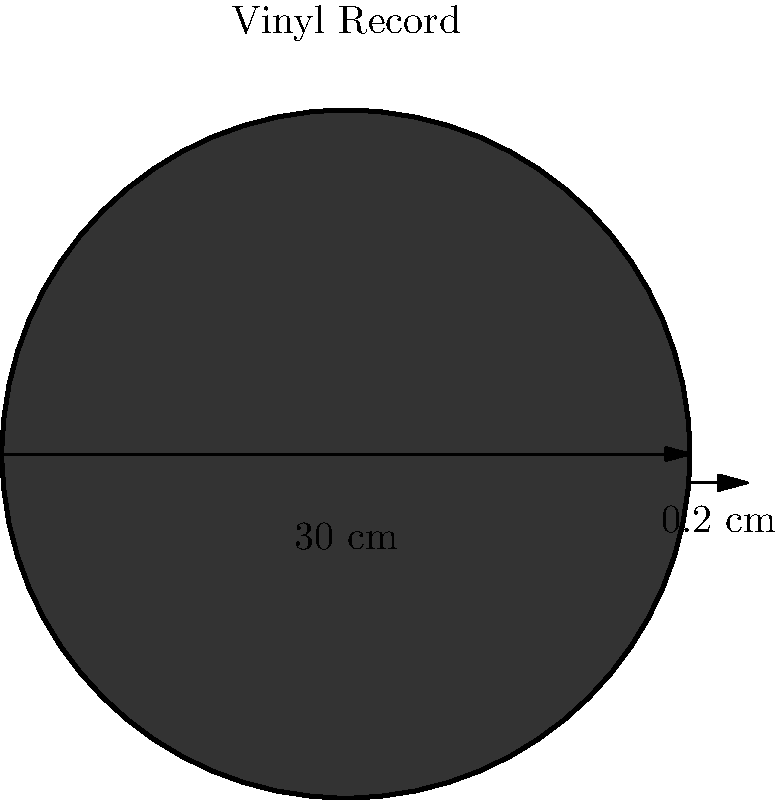As a vinyl record collector, you're curious about the volume of your favorite records. Given a standard 12-inch vinyl record with a diameter of 30 cm and a thickness of 0.2 cm, calculate its volume in cubic centimeters (cm³). Round your answer to the nearest whole number. To calculate the volume of a cylindrical vinyl record, we need to use the formula for the volume of a cylinder:

$$V = \pi r^2 h$$

Where:
$V$ = volume
$r$ = radius of the base
$h$ = height (thickness) of the cylinder

Step 1: Calculate the radius
The diameter is 30 cm, so the radius is half of that:
$$r = \frac{30 \text{ cm}}{2} = 15 \text{ cm}$$

Step 2: Identify the thickness (height)
The thickness is given as 0.2 cm.

Step 3: Apply the volume formula
$$V = \pi (15 \text{ cm})^2 (0.2 \text{ cm})$$

Step 4: Calculate
$$V = \pi (225 \text{ cm}^2) (0.2 \text{ cm})$$
$$V = 45\pi \text{ cm}^3$$
$$V \approx 141.37 \text{ cm}^3$$

Step 5: Round to the nearest whole number
$$V \approx 141 \text{ cm}^3$$
Answer: 141 cm³ 